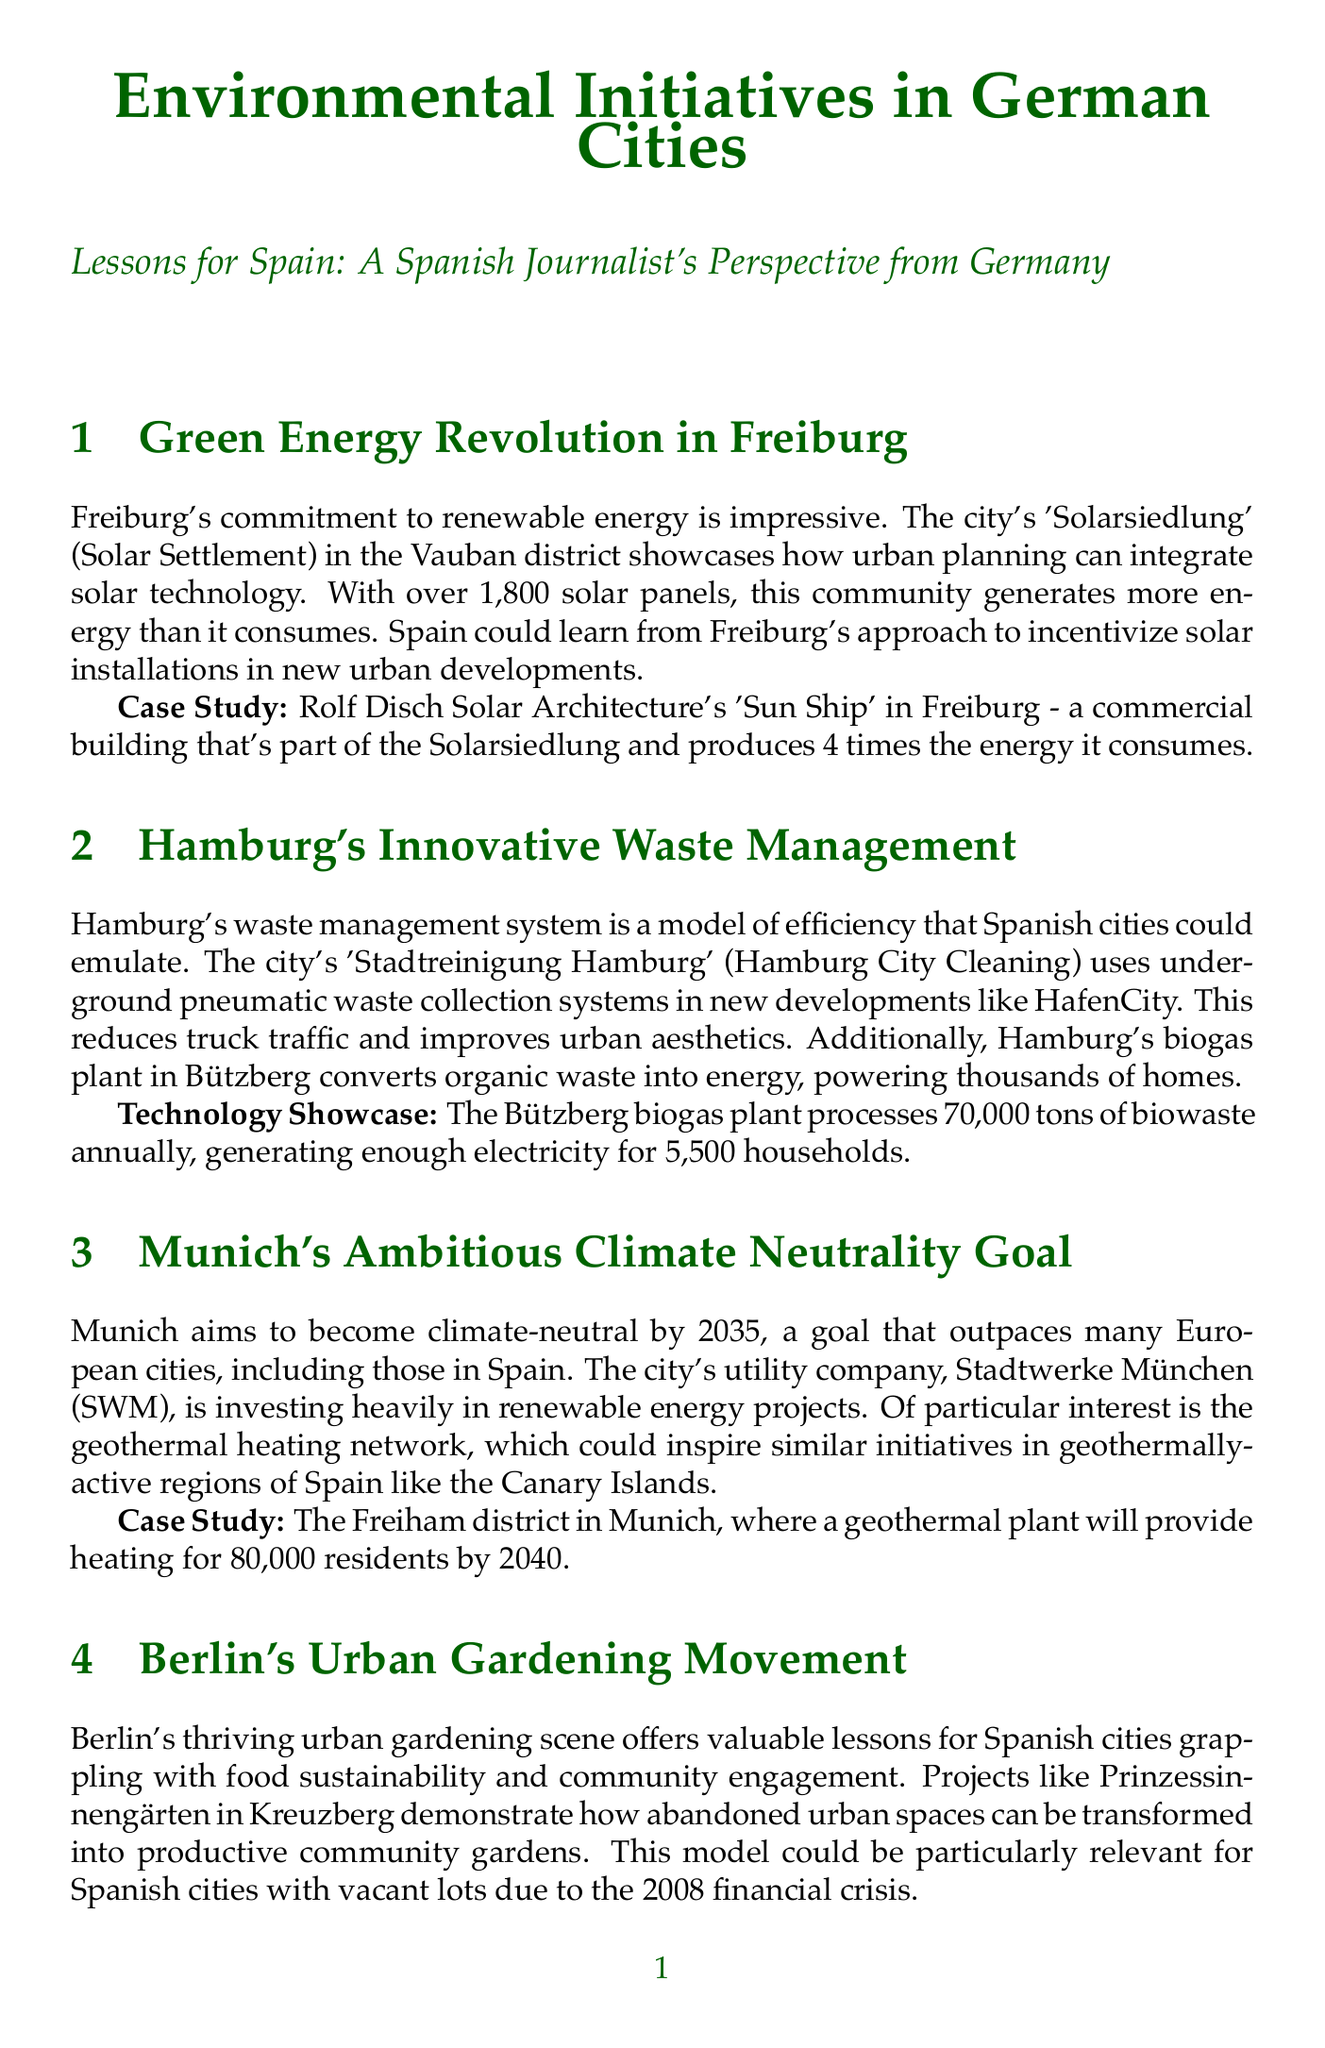What is the name of Freiburg's solar community? The document refers to Freiburg's solar community as 'Solarsiedlung' (Solar Settlement).
Answer: Solarsiedlung How many solar panels are in Freiburg's 'Solarsiedlung'? The document states that there are over 1,800 solar panels in Freiburg's 'Solarsiedlung'.
Answer: 1,800 What is the goal year for Munich's climate neutrality? The document mentions that Munich aims to become climate-neutral by 2035.
Answer: 2035 What technology does Hamburg's biogas plant use? The document indicates that Hamburg's biogas plant converts organic waste into energy.
Answer: Biogas Which district in Munich will have geothermal heating? The document specifies that the Freiham district in Munich will have a geothermal plant.
Answer: Freiham What is the name of the bicycle highway in Düsseldorf? The document refers to the bicycle highway as Radschnellweg 1 (RS1).
Answer: Radschnellweg 1 What is a significant benefit of Hamburg's underground waste collection? The document highlights that the underground waste collection reduces truck traffic and improves urban aesthetics.
Answer: Truck traffic reduction What community initiative is highlighted in Berlin? The document discusses the urban gardening initiative named Prinzessinnengärten.
Answer: Prinzessinnengärten 